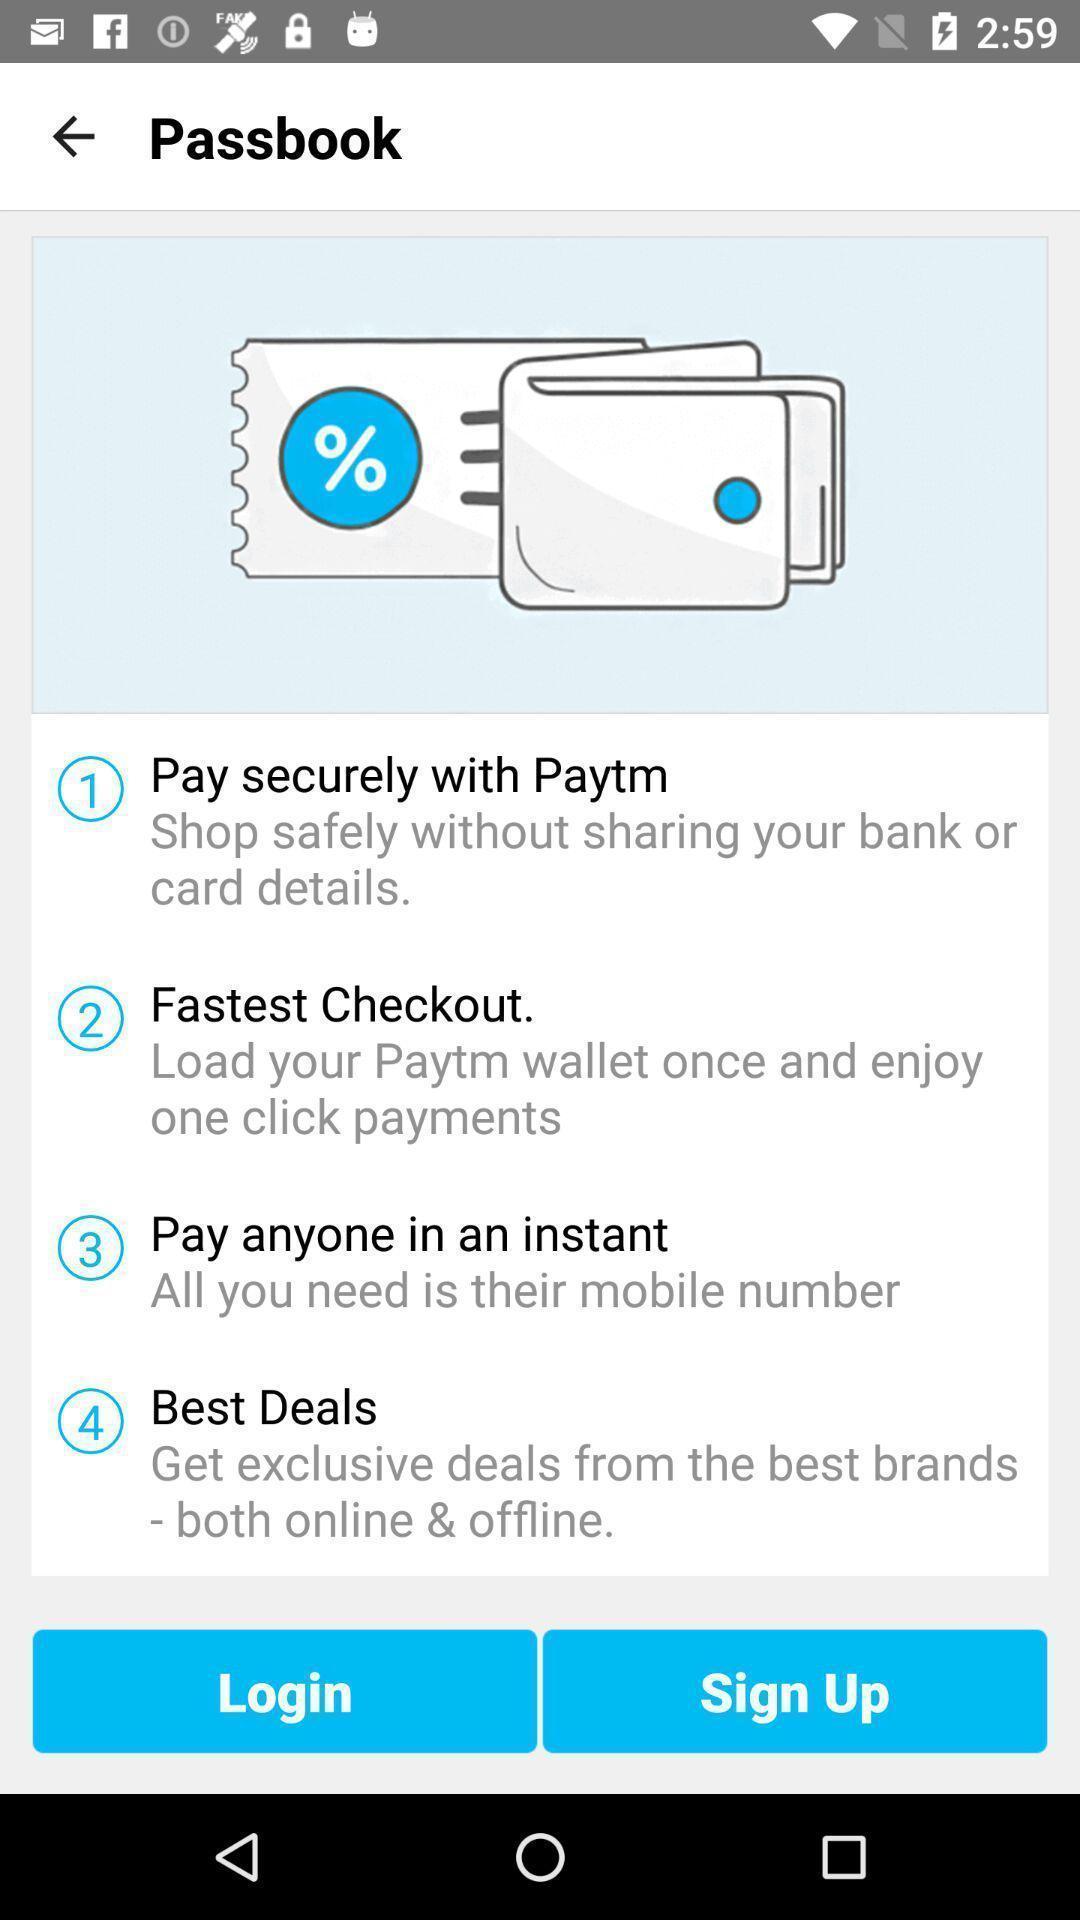Describe this image in words. Login-in page for a financial app. 